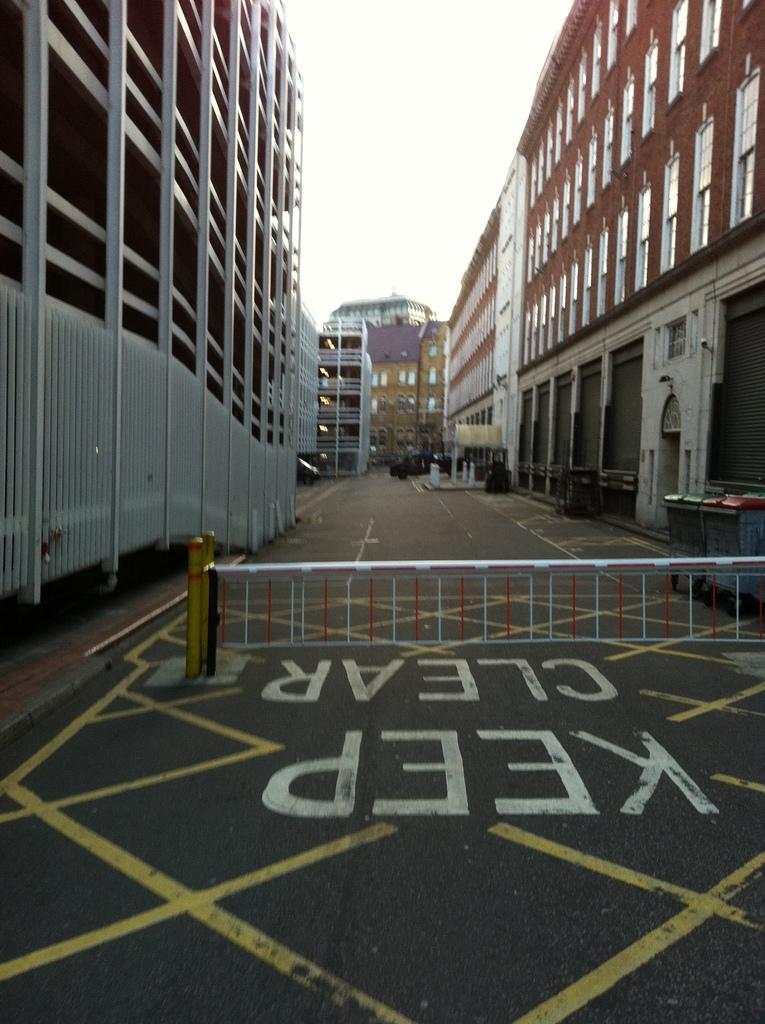What is located on the road in the image? There is a fence on the road in the image. What can be seen beside the fence in the image? There are buildings beside the fence in the image. Where is the key to the tub located in the image? There is no tub or key present in the image; it only features a fence and buildings. 